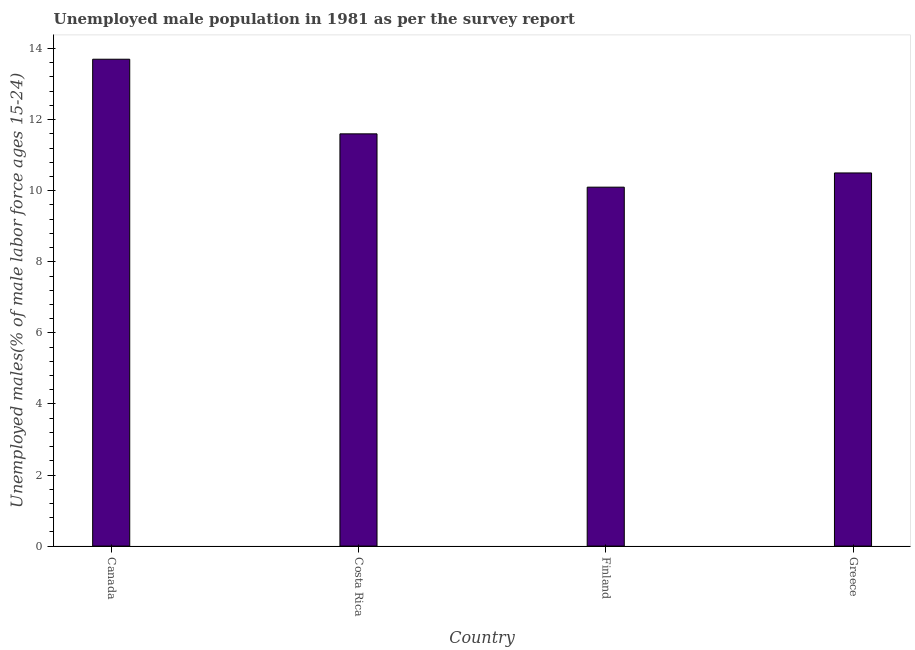Does the graph contain any zero values?
Your answer should be compact. No. What is the title of the graph?
Offer a very short reply. Unemployed male population in 1981 as per the survey report. What is the label or title of the Y-axis?
Your response must be concise. Unemployed males(% of male labor force ages 15-24). What is the unemployed male youth in Canada?
Your response must be concise. 13.7. Across all countries, what is the maximum unemployed male youth?
Provide a short and direct response. 13.7. Across all countries, what is the minimum unemployed male youth?
Give a very brief answer. 10.1. In which country was the unemployed male youth minimum?
Provide a short and direct response. Finland. What is the sum of the unemployed male youth?
Your answer should be compact. 45.9. What is the average unemployed male youth per country?
Your response must be concise. 11.47. What is the median unemployed male youth?
Your answer should be very brief. 11.05. In how many countries, is the unemployed male youth greater than 8.4 %?
Provide a short and direct response. 4. What is the ratio of the unemployed male youth in Canada to that in Greece?
Your answer should be very brief. 1.3. Is the difference between the unemployed male youth in Costa Rica and Finland greater than the difference between any two countries?
Provide a short and direct response. No. Is the sum of the unemployed male youth in Finland and Greece greater than the maximum unemployed male youth across all countries?
Offer a terse response. Yes. In how many countries, is the unemployed male youth greater than the average unemployed male youth taken over all countries?
Offer a very short reply. 2. How many bars are there?
Give a very brief answer. 4. Are all the bars in the graph horizontal?
Provide a succinct answer. No. Are the values on the major ticks of Y-axis written in scientific E-notation?
Your response must be concise. No. What is the Unemployed males(% of male labor force ages 15-24) of Canada?
Your response must be concise. 13.7. What is the Unemployed males(% of male labor force ages 15-24) in Costa Rica?
Offer a terse response. 11.6. What is the Unemployed males(% of male labor force ages 15-24) of Finland?
Offer a terse response. 10.1. What is the difference between the Unemployed males(% of male labor force ages 15-24) in Canada and Finland?
Your answer should be very brief. 3.6. What is the difference between the Unemployed males(% of male labor force ages 15-24) in Costa Rica and Finland?
Give a very brief answer. 1.5. What is the ratio of the Unemployed males(% of male labor force ages 15-24) in Canada to that in Costa Rica?
Make the answer very short. 1.18. What is the ratio of the Unemployed males(% of male labor force ages 15-24) in Canada to that in Finland?
Ensure brevity in your answer.  1.36. What is the ratio of the Unemployed males(% of male labor force ages 15-24) in Canada to that in Greece?
Give a very brief answer. 1.3. What is the ratio of the Unemployed males(% of male labor force ages 15-24) in Costa Rica to that in Finland?
Provide a short and direct response. 1.15. What is the ratio of the Unemployed males(% of male labor force ages 15-24) in Costa Rica to that in Greece?
Offer a terse response. 1.1. What is the ratio of the Unemployed males(% of male labor force ages 15-24) in Finland to that in Greece?
Ensure brevity in your answer.  0.96. 